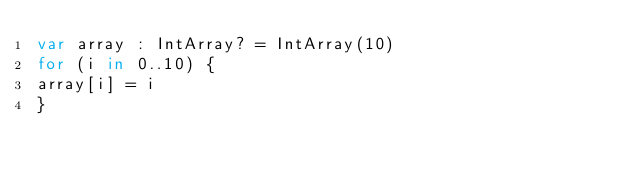Convert code to text. <code><loc_0><loc_0><loc_500><loc_500><_Kotlin_>var array : IntArray? = IntArray(10)
for (i in 0..10) {
array[i] = i
}</code> 